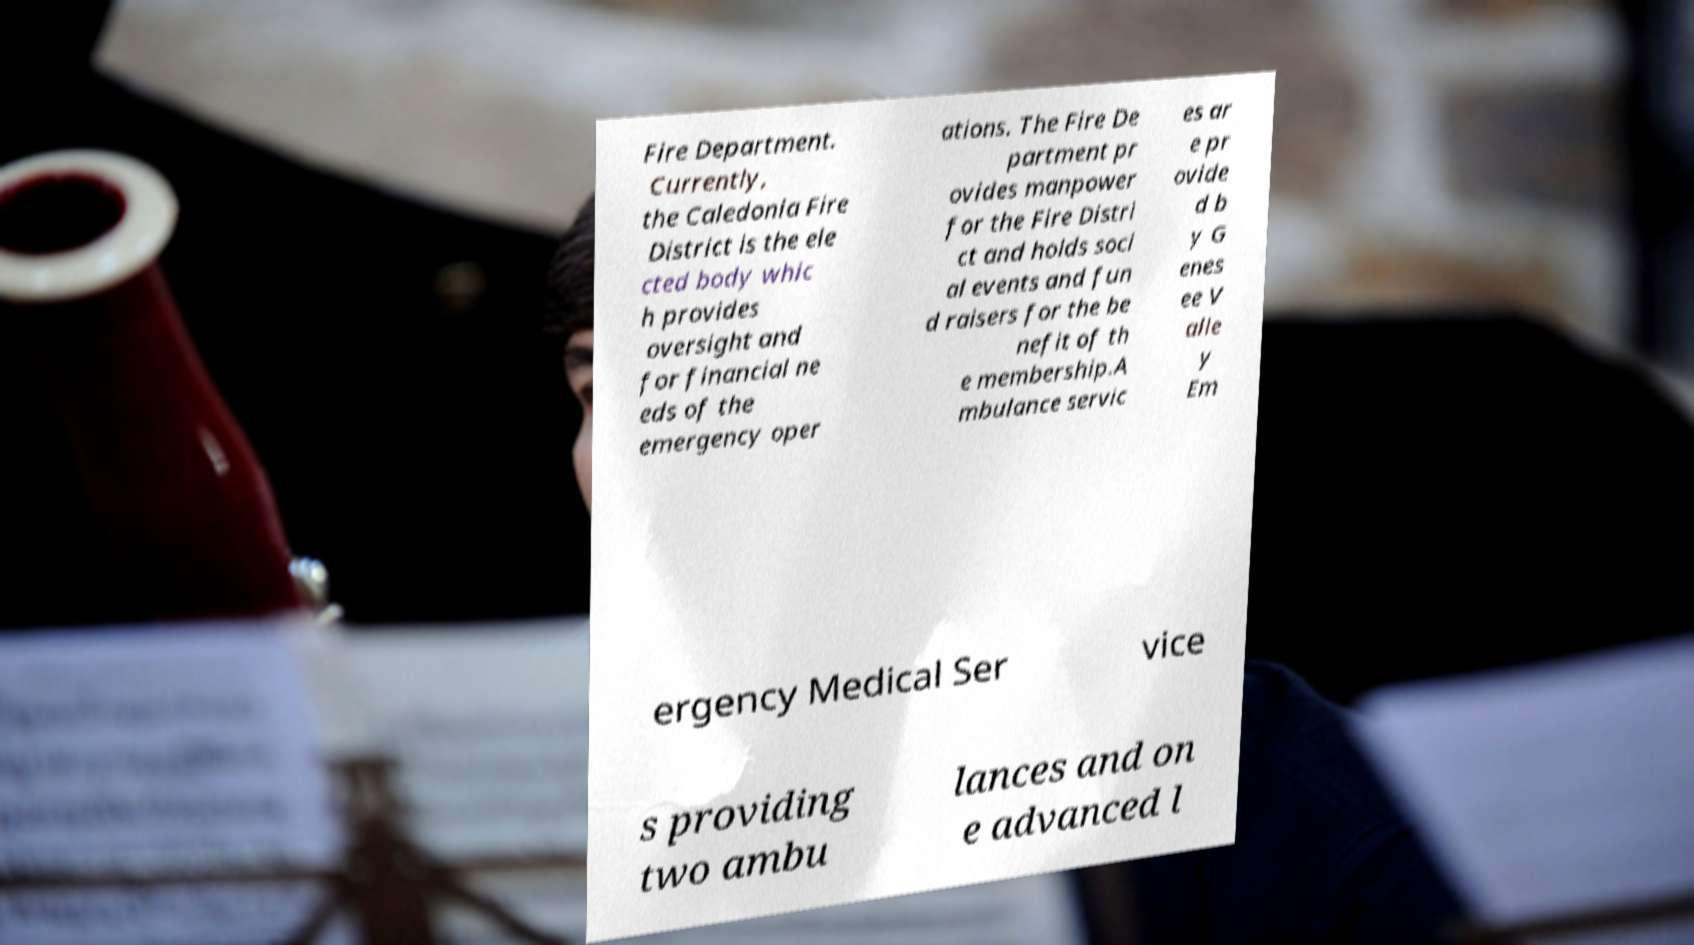Can you accurately transcribe the text from the provided image for me? Fire Department. Currently, the Caledonia Fire District is the ele cted body whic h provides oversight and for financial ne eds of the emergency oper ations. The Fire De partment pr ovides manpower for the Fire Distri ct and holds soci al events and fun d raisers for the be nefit of th e membership.A mbulance servic es ar e pr ovide d b y G enes ee V alle y Em ergency Medical Ser vice s providing two ambu lances and on e advanced l 